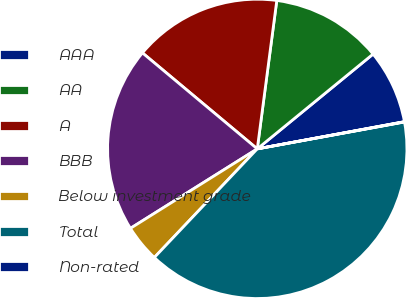<chart> <loc_0><loc_0><loc_500><loc_500><pie_chart><fcel>AAA<fcel>AA<fcel>A<fcel>BBB<fcel>Below investment grade<fcel>Total<fcel>Non-rated<nl><fcel>8.01%<fcel>12.0%<fcel>16.0%<fcel>19.99%<fcel>4.02%<fcel>39.95%<fcel>0.03%<nl></chart> 